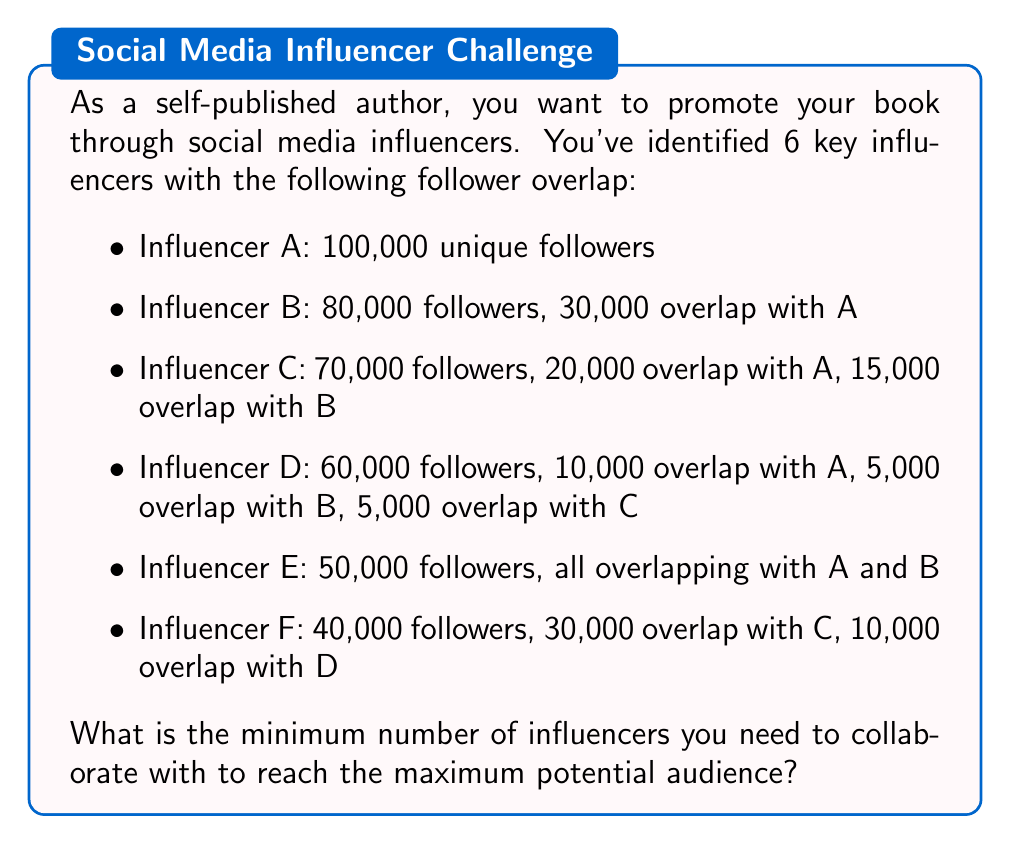Help me with this question. To solve this problem, we can use the concept of set cover from graph theory. We need to find the smallest subset of influencers that covers all unique followers.

Let's break down the problem step-by-step:

1. First, let's calculate the total unique followers for each influencer:

   A: 100,000
   B: 80,000 - 30,000 = 50,000 unique
   C: 70,000 - 20,000 - 15,000 = 35,000 unique
   D: 60,000 - 10,000 - 5,000 - 5,000 = 40,000 unique
   E: 0 unique (all followers overlap with A and B)
   F: 40,000 - 30,000 - 10,000 = 0 unique

2. We can represent this as a set cover problem:
   
   $$ U = \{A, B, C, D\} $$
   
   Where U is the universe of all unique follower sets.

3. We need to find the minimum number of sets that cover all unique followers. Let's start with the largest set:

   Step 1: Choose A (100,000 followers)
   Remaining: B (50,000), C (35,000), D (40,000)

   Step 2: Choose D (40,000 followers)
   Remaining: B (50,000), C (30,000)

   Step 3: Choose B (50,000 followers)
   Remaining: C (15,000)

   Step 4: Choose C (15,000 followers)
   All unique followers are now covered.

4. We can verify that this is the minimum number of influencers needed:
   - We can't remove A as it has the largest unique following.
   - We can't remove D as it covers 40,000 unique followers not covered by A.
   - We can't remove B as it covers 50,000 unique followers not covered by A or D.
   - We can't remove C as it covers the remaining 15,000 unique followers.

Therefore, the minimum number of influencers needed is 4: A, B, C, and D.
Answer: 4 influencers 